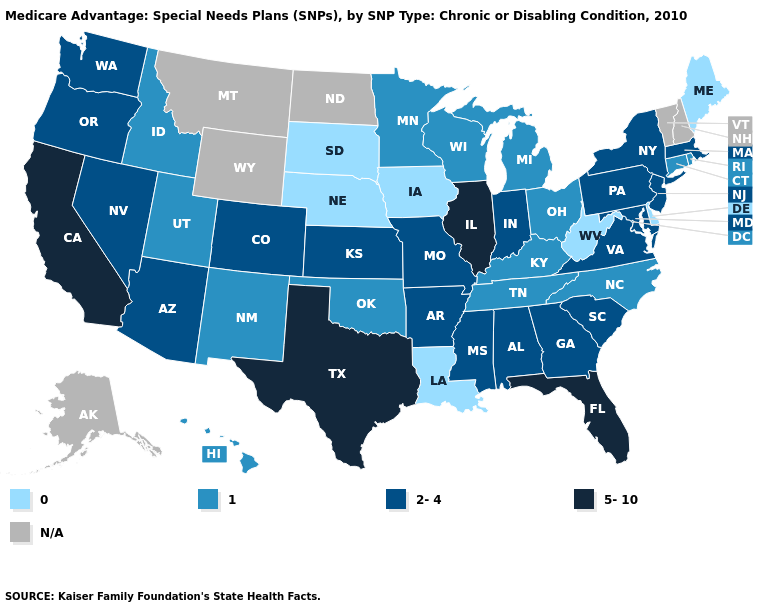What is the value of Indiana?
Short answer required. 2-4. Name the states that have a value in the range 0?
Be succinct. Delaware, Iowa, Louisiana, Maine, Nebraska, South Dakota, West Virginia. Does the map have missing data?
Be succinct. Yes. Name the states that have a value in the range 5-10?
Answer briefly. California, Florida, Illinois, Texas. Which states have the highest value in the USA?
Short answer required. California, Florida, Illinois, Texas. Does the map have missing data?
Quick response, please. Yes. Name the states that have a value in the range 2-4?
Write a very short answer. Alabama, Arkansas, Arizona, Colorado, Georgia, Indiana, Kansas, Massachusetts, Maryland, Missouri, Mississippi, New Jersey, Nevada, New York, Oregon, Pennsylvania, South Carolina, Virginia, Washington. What is the lowest value in the USA?
Quick response, please. 0. Among the states that border Nevada , does California have the highest value?
Concise answer only. Yes. Is the legend a continuous bar?
Answer briefly. No. What is the highest value in the USA?
Write a very short answer. 5-10. Name the states that have a value in the range 5-10?
Answer briefly. California, Florida, Illinois, Texas. Name the states that have a value in the range N/A?
Answer briefly. Alaska, Montana, North Dakota, New Hampshire, Vermont, Wyoming. 